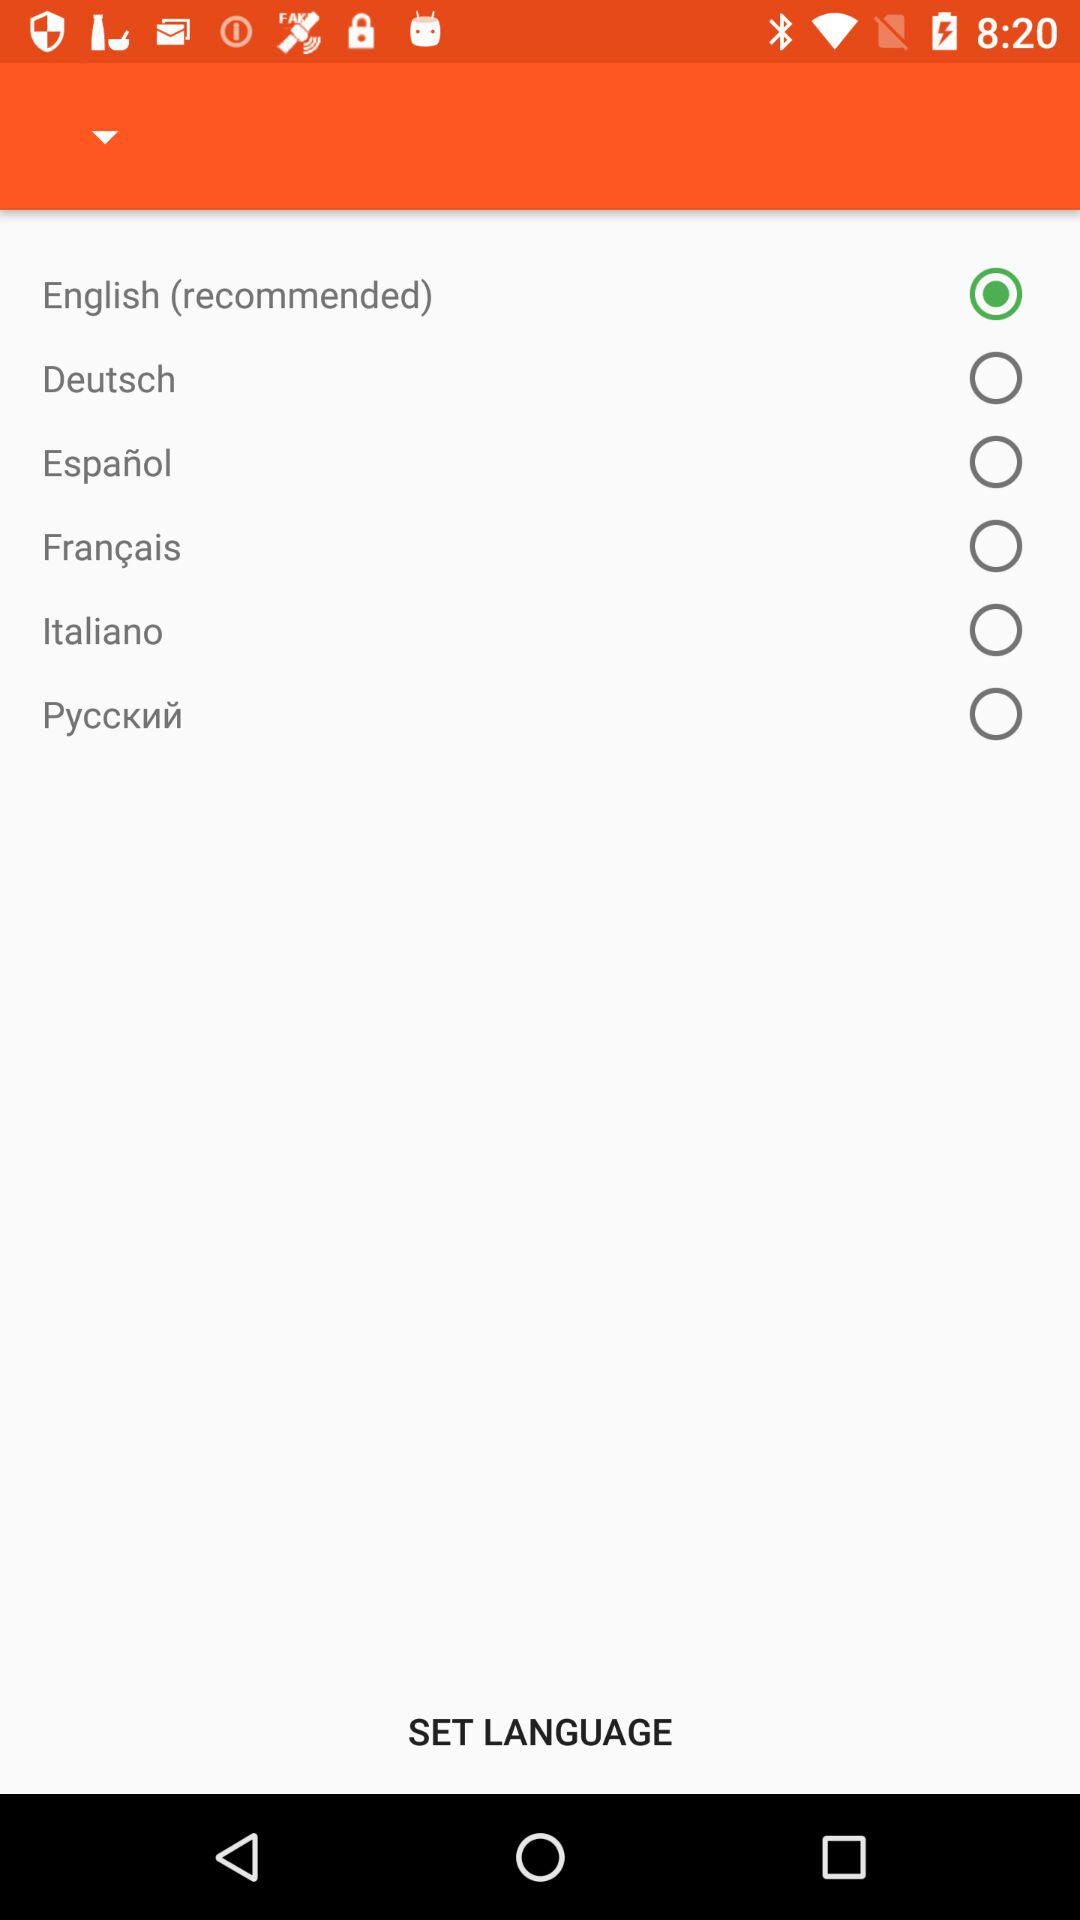Is Deutsch selected or not? The Deutsch is "not selected". 